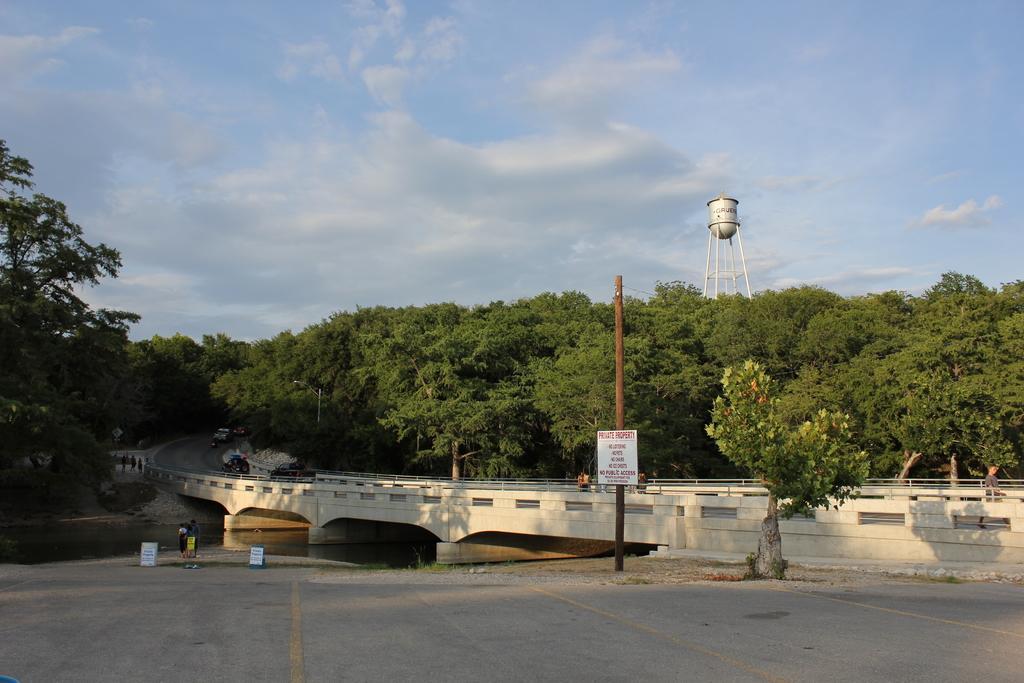Please provide a concise description of this image. In this image there is a bridge having few persons and vehicles on it. Under the bridge there is water. Bottom of the image there is a road. Beside the road there is a pole having a board attached to it. There is a tree on the pavement. Background there are few trees. Behind there is a tank. Top of the image there is sky having some clouds. 